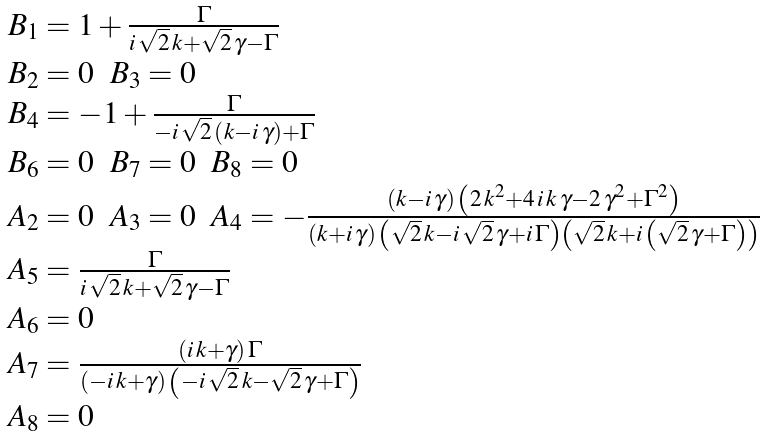Convert formula to latex. <formula><loc_0><loc_0><loc_500><loc_500>\begin{array} { l } { { B _ { 1 } } = { 1 + { \frac { \Gamma } { i \, { \sqrt { 2 } } \, k + { \sqrt { 2 } } \, \gamma - \Gamma } } } } \\ { { B _ { 2 } } = 0 } \ \ { { B _ { 3 } } = 0 } \\ { { B _ { 4 } } = { - 1 + { \frac { \Gamma } { - i \, { \sqrt { 2 } } \, \left ( k - i \, \gamma \right ) + \Gamma } } } } \\ { { B _ { 6 } } = 0 } \ \ { { B _ { 7 } } = 0 } \ \ { { B _ { 8 } } = 0 } \\ { { A _ { 2 } } = 0 } \ \ { { A _ { 3 } } = 0 } \ \ { { A _ { 4 } } = { - { \frac { \left ( k - i \, \gamma \right ) \, \left ( 2 \, { k ^ { 2 } } + 4 \, i \, k \, \gamma - 2 \, { { \gamma } ^ { 2 } } + { { \Gamma } ^ { 2 } } \right ) } { \left ( k + i \, \gamma \right ) \, \left ( { \sqrt { 2 } } \, k - i \, { \sqrt { 2 } } \, \gamma + i \, \Gamma \right ) \left ( { \sqrt { 2 } } \, k + i \, \left ( { \sqrt { 2 } } \, \gamma + \Gamma \right ) \right ) } } } } \\ { { A _ { 5 } } = { { \frac { \Gamma } { i \, { \sqrt { 2 } } \, k + { \sqrt { 2 } } \, \gamma - \Gamma } } } } \\ { { A _ { 6 } } = 0 } \\ { { A _ { 7 } } = { { \frac { \left ( i \, k + \gamma \right ) \, \Gamma } { \left ( - i \, k + \gamma \right ) \, \left ( - i \, { \sqrt { 2 } } \, k - { \sqrt { 2 } } \, \gamma + \Gamma \right ) } } } } \\ { { A _ { 8 } } = 0 } \end{array}</formula> 